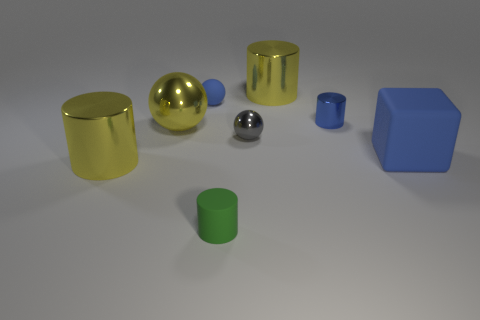What size is the cube that is the same color as the tiny matte ball?
Your answer should be compact. Large. Do the matte object behind the small metallic cylinder and the big metallic cylinder in front of the block have the same color?
Offer a very short reply. No. What is the size of the blue sphere?
Give a very brief answer. Small. What number of big things are gray things or rubber things?
Your response must be concise. 1. What is the color of the rubber thing that is the same size as the yellow ball?
Give a very brief answer. Blue. What number of other things are the same shape as the small gray object?
Provide a succinct answer. 2. Is there a small cube made of the same material as the gray ball?
Ensure brevity in your answer.  No. Are the small cylinder behind the big metallic sphere and the large cylinder that is behind the yellow shiny ball made of the same material?
Provide a short and direct response. Yes. How many small blue metal cylinders are there?
Offer a very short reply. 1. There is a small matte object left of the small green thing; what shape is it?
Ensure brevity in your answer.  Sphere. 